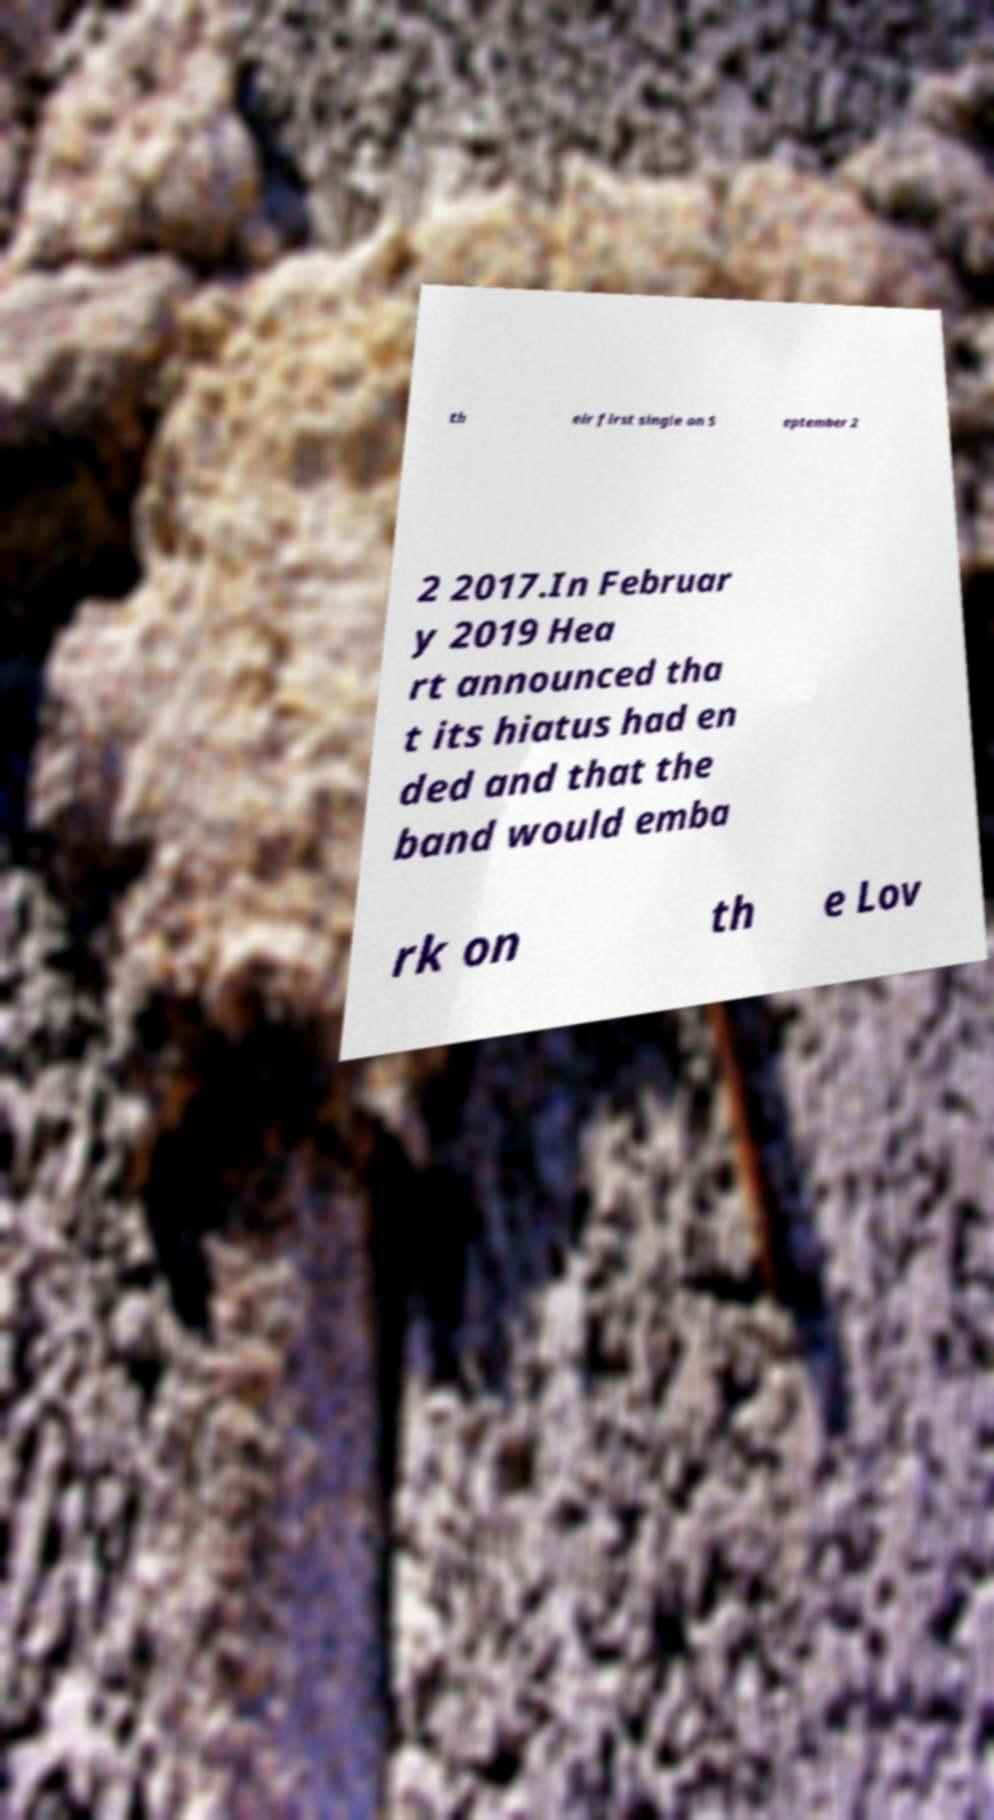For documentation purposes, I need the text within this image transcribed. Could you provide that? th eir first single on S eptember 2 2 2017.In Februar y 2019 Hea rt announced tha t its hiatus had en ded and that the band would emba rk on th e Lov 